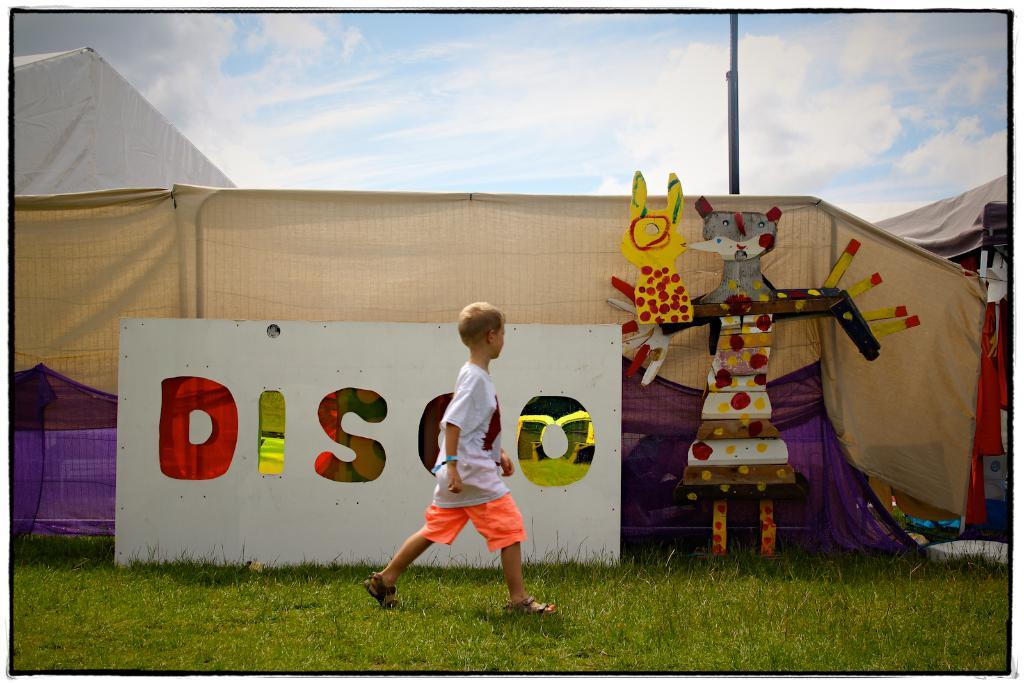<image>
Relay a brief, clear account of the picture shown. A boy in orange shorts is walking past the disco sign. 